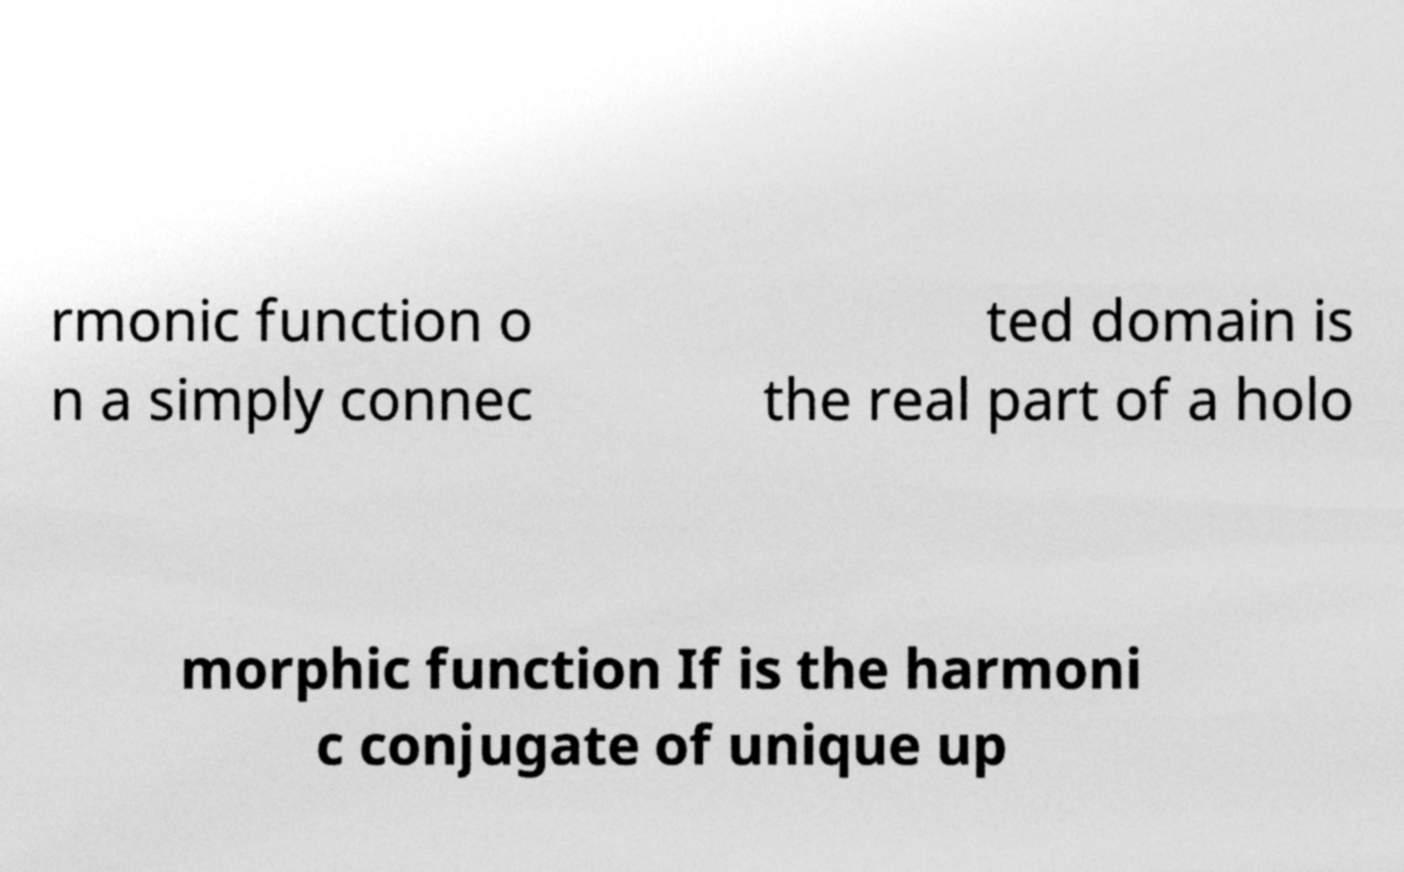I need the written content from this picture converted into text. Can you do that? rmonic function o n a simply connec ted domain is the real part of a holo morphic function If is the harmoni c conjugate of unique up 